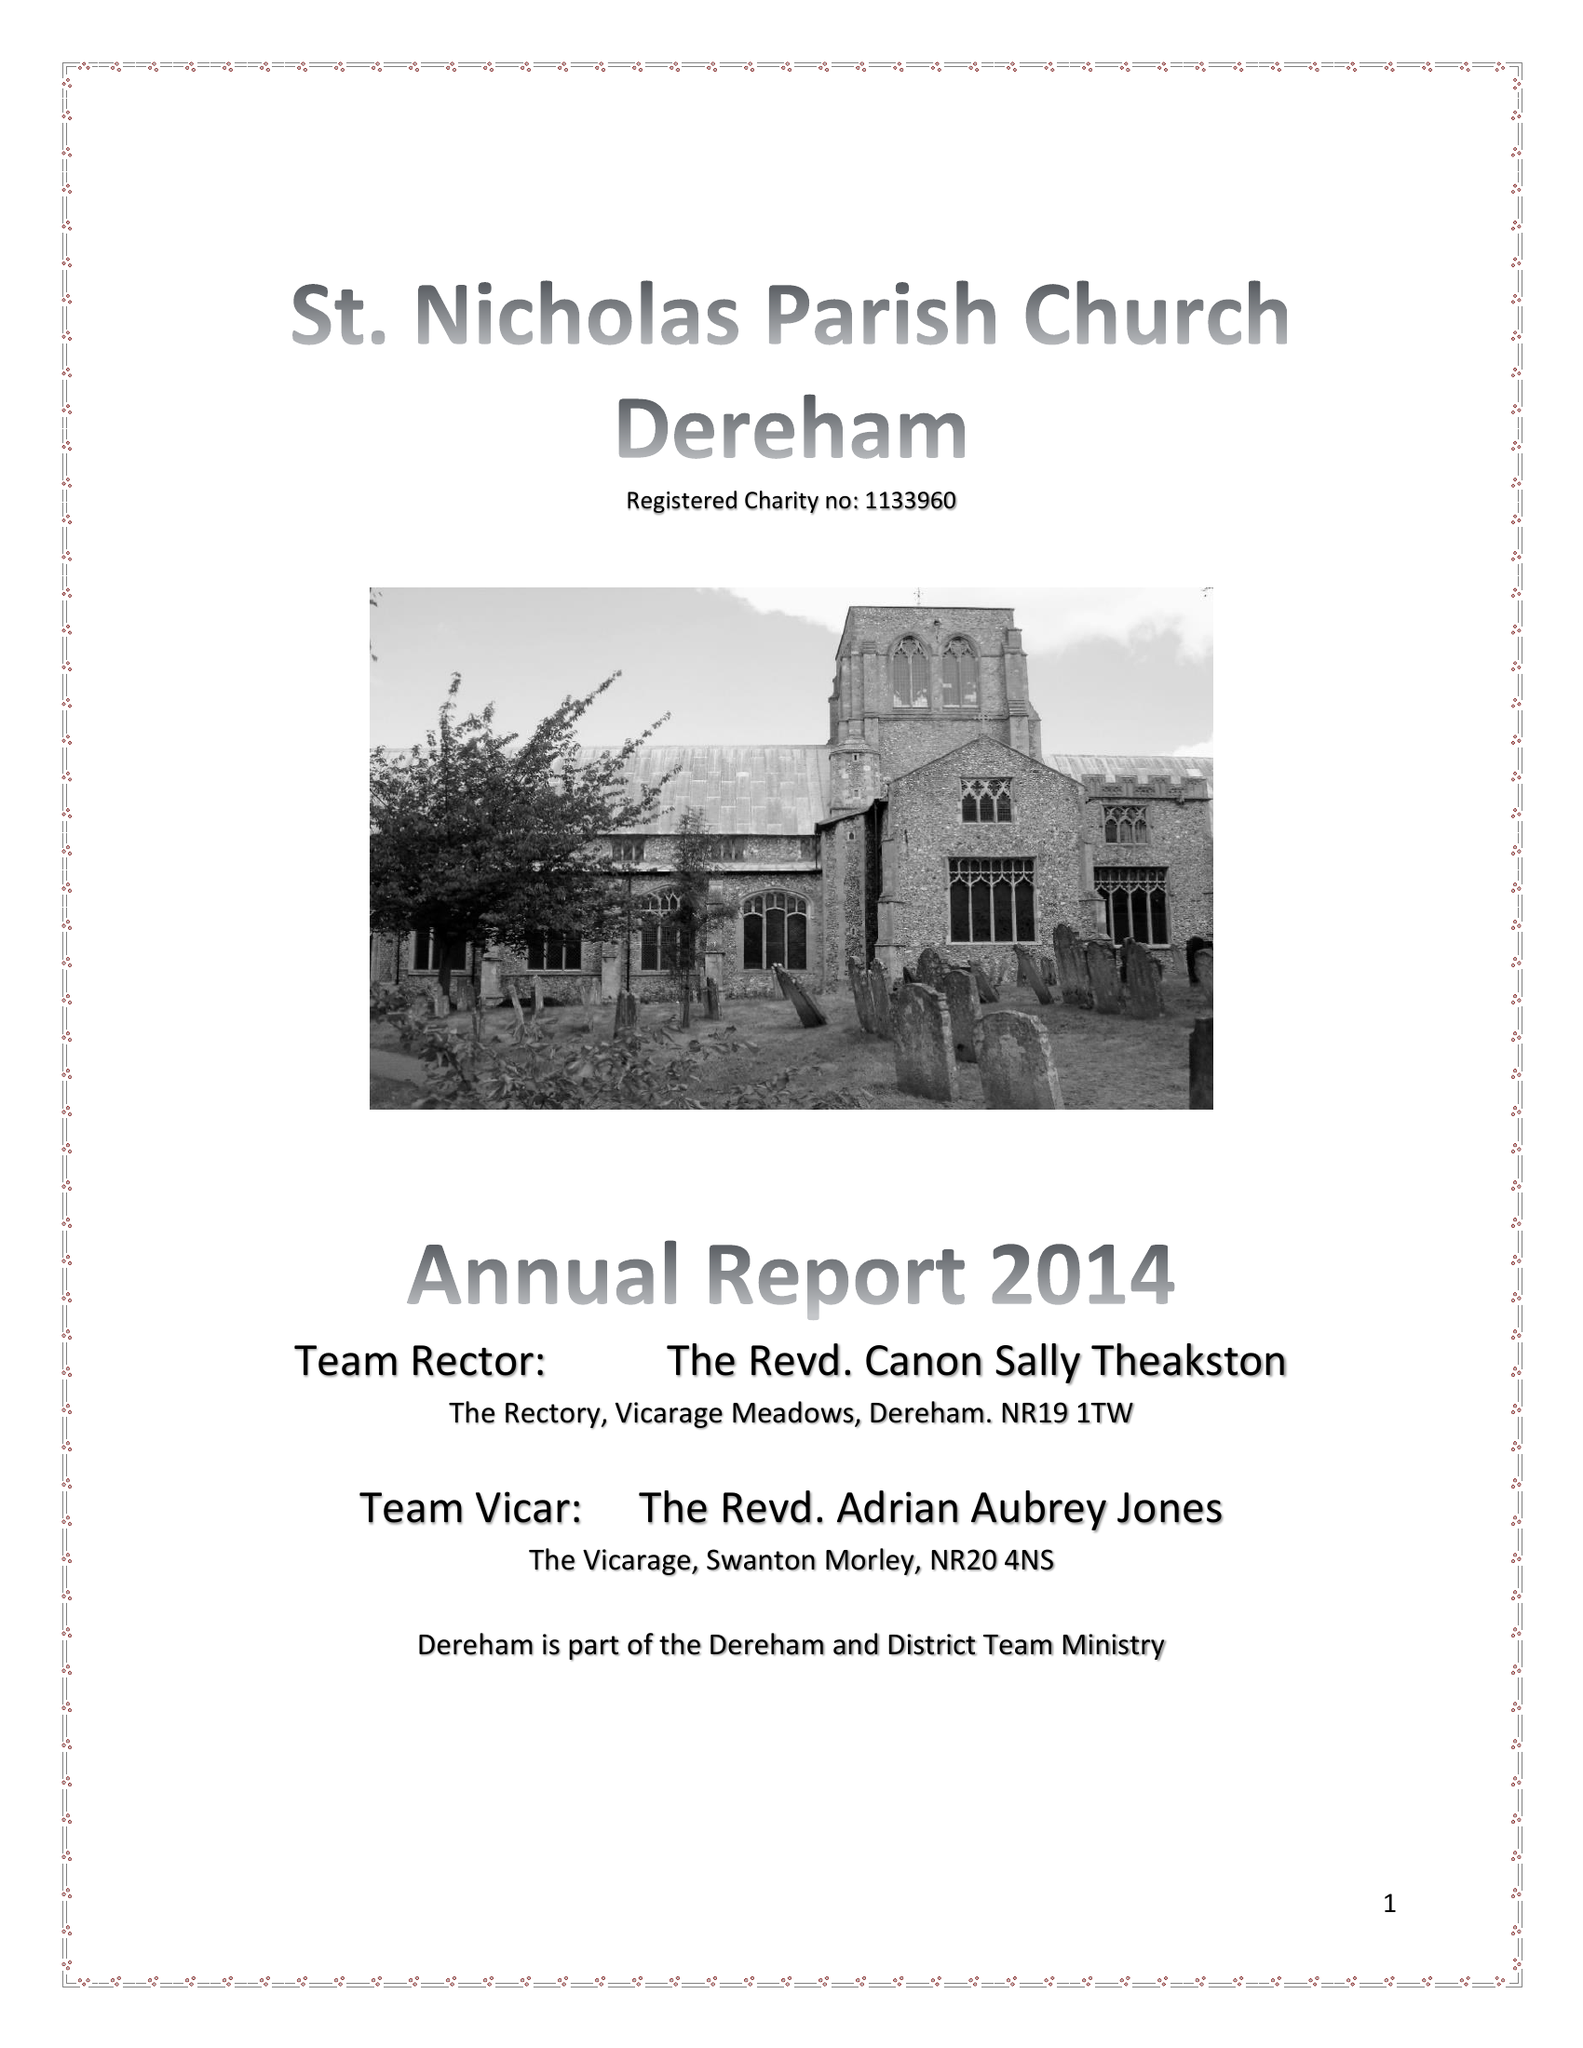What is the value for the report_date?
Answer the question using a single word or phrase. 2014-12-31 